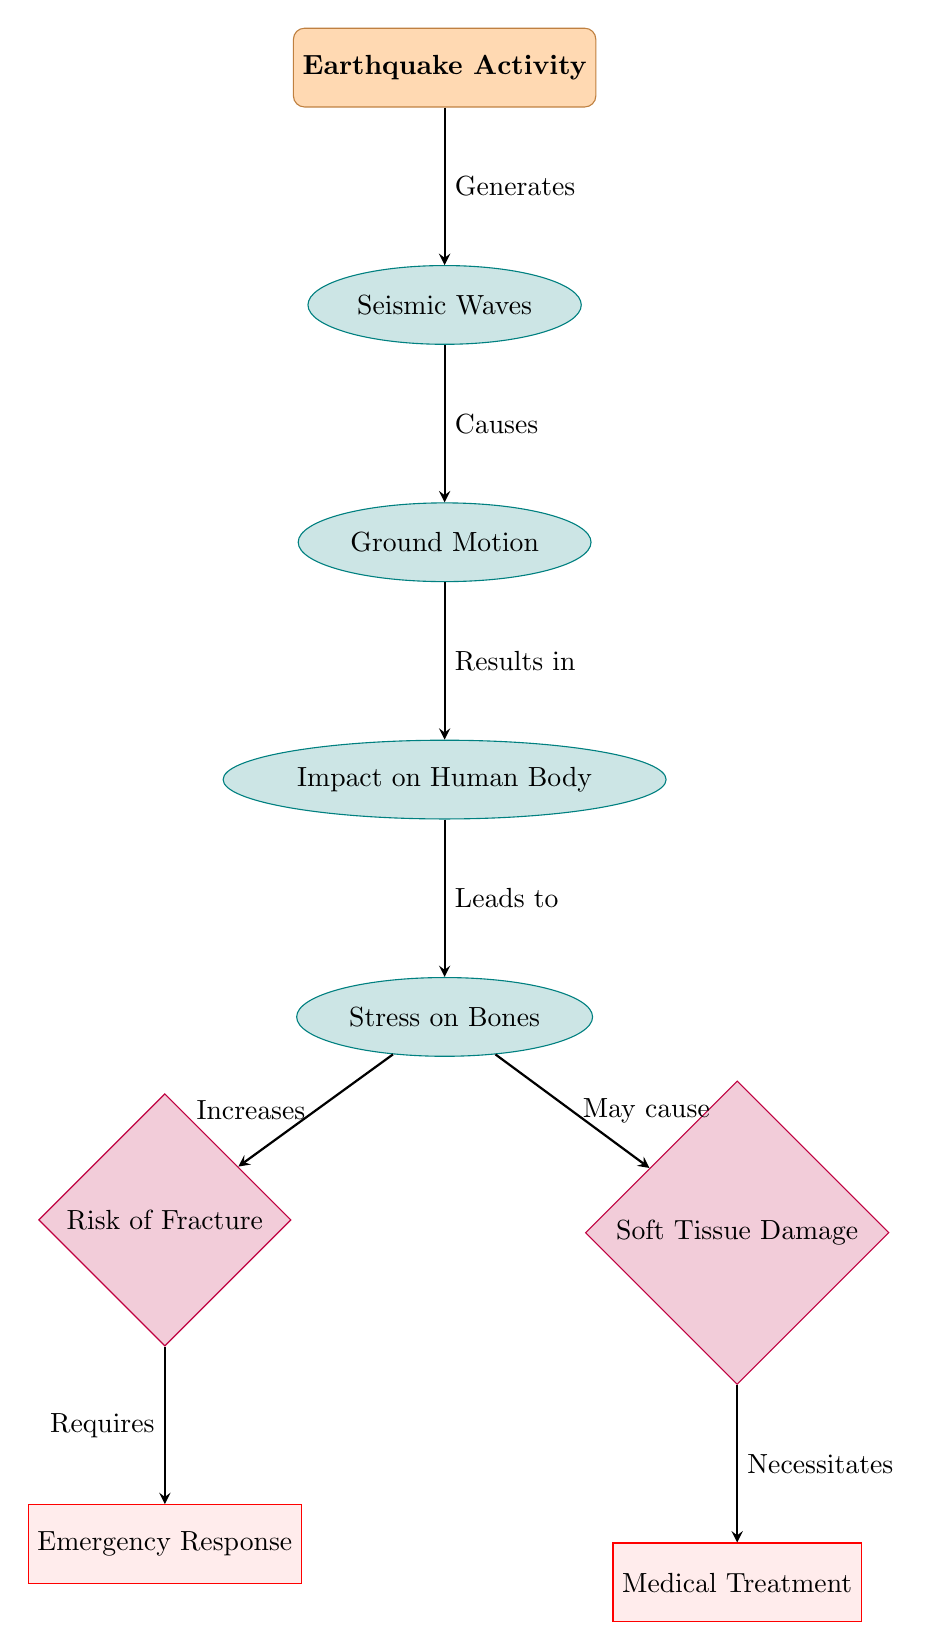What is the first node in the diagram? The first node, which is the root node at the top of the diagram, is labeled "Earthquake Activity".
Answer: Earthquake Activity What does seismic waves cause? According to the arrows in the diagram, seismic waves cause ground motion.
Answer: Ground Motion How many outcome nodes are there in the diagram? The diagram includes two outcome nodes, which are "Risk of Fracture" and "Soft Tissue Damage".
Answer: Two Which node is directly below "Impact on Human Body"? The node directly below "Impact on Human Body" is "Stress on Bones".
Answer: Stress on Bones What action is required after a risk of fracture? The action required after a risk of fracture is "Emergency Response", as indicated by the arrow leading from "Risk of Fracture" to it.
Answer: Emergency Response What happens to bones as a result of ground motion? The diagram shows that as a result of ground motion, there is an increase in stress on bones.
Answer: Increases What necessitates medical treatment in this diagram? The diagram indicates that soft tissue damage necessitates medical treatment, as shown by the connection from "Soft Tissue Damage" to "Medical Treatment".
Answer: Medical Treatment How does the diagram represent the flow of effects from the earthquake? The diagram visually represents the flow of effects by using arrows that direct from one node to another, starting from "Earthquake Activity" to the outcomes related to the human body's response.
Answer: Through arrows What does the last node represent in relation to the human body? The last node, "Soft Tissue Damage", represents an outcome related to the impact on human body caused by earthquake-induced stress.
Answer: Soft Tissue Damage 